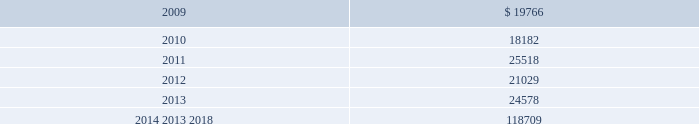Mastercard incorporated notes to consolidated financial statements 2014 ( continued ) ( in thousands , except percent and per share data ) the table summarizes expected benefit payments through 2018 including those payments expected to be paid from the company 2019s general assets .
Since the majority of the benefit payments are made in the form of lump-sum distributions , actual benefit payments may differ from expected benefits payments. .
Substantially all of the company 2019s u.s .
Employees are eligible to participate in a defined contribution savings plan ( the 201csavings plan 201d ) sponsored by the company .
The savings plan allows employees to contribute a portion of their base compensation on a pre-tax and after-tax basis in accordance with specified guidelines .
The company matches a percentage of employees 2019 contributions up to certain limits .
In 2007 and prior years , the company could also contribute to the savings plan a discretionary profit sharing component linked to company performance during the prior year .
Beginning in 2008 , the discretionary profit sharing amount related to 2007 company performance was paid directly to employees as a short-term cash incentive bonus rather than as a contribution to the savings plan .
In addition , the company has several defined contribution plans outside of the united states .
The company 2019s contribution expense related to all of its defined contribution plans was $ 35341 , $ 26996 and $ 43594 for 2008 , 2007 and 2006 , respectively .
The company had a value appreciation program ( 201cvap 201d ) , which was an incentive compensation plan established in 1995 .
Annual awards were granted to vap participants from 1995 through 1998 , which entitled participants to the net appreciation on a portfolio of securities of members of mastercard international .
In 1999 , the vap was replaced by an executive incentive plan ( 201ceip 201d ) and the senior executive incentive plan ( 201cseip 201d ) ( together the 201ceip plans 201d ) ( see note 16 ( share based payments and other benefits ) ) .
Contributions to the vap have been discontinued , all plan assets have been disbursed and no vap liability remained as of december 31 , 2008 .
The company 2019s liability related to the vap at december 31 , 2007 was $ 986 .
The expense ( benefit ) was $ ( 6 ) , $ ( 267 ) and $ 3406 for the years ended december 31 , 2008 , 2007 and 2006 , respectively .
Note 12 .
Postemployment and postretirement benefits the company maintains a postretirement plan ( the 201cpostretirement plan 201d ) providing health coverage and life insurance benefits for substantially all of its u.s .
Employees and retirees hired before july 1 , 2007 .
The company amended the life insurance benefits under the postretirement plan effective january 1 , 2007 .
The impact , net of taxes , of this amendment was an increase of $ 1715 to accumulated other comprehensive income in 2007. .
What is the ratio of the expected benefit payments for 2009 to 2010? 
Rationale: the ratio of the expected benefit payments in 2009 to 2010 was 1.087
Computations: (19766 / 18182)
Answer: 1.08712. 